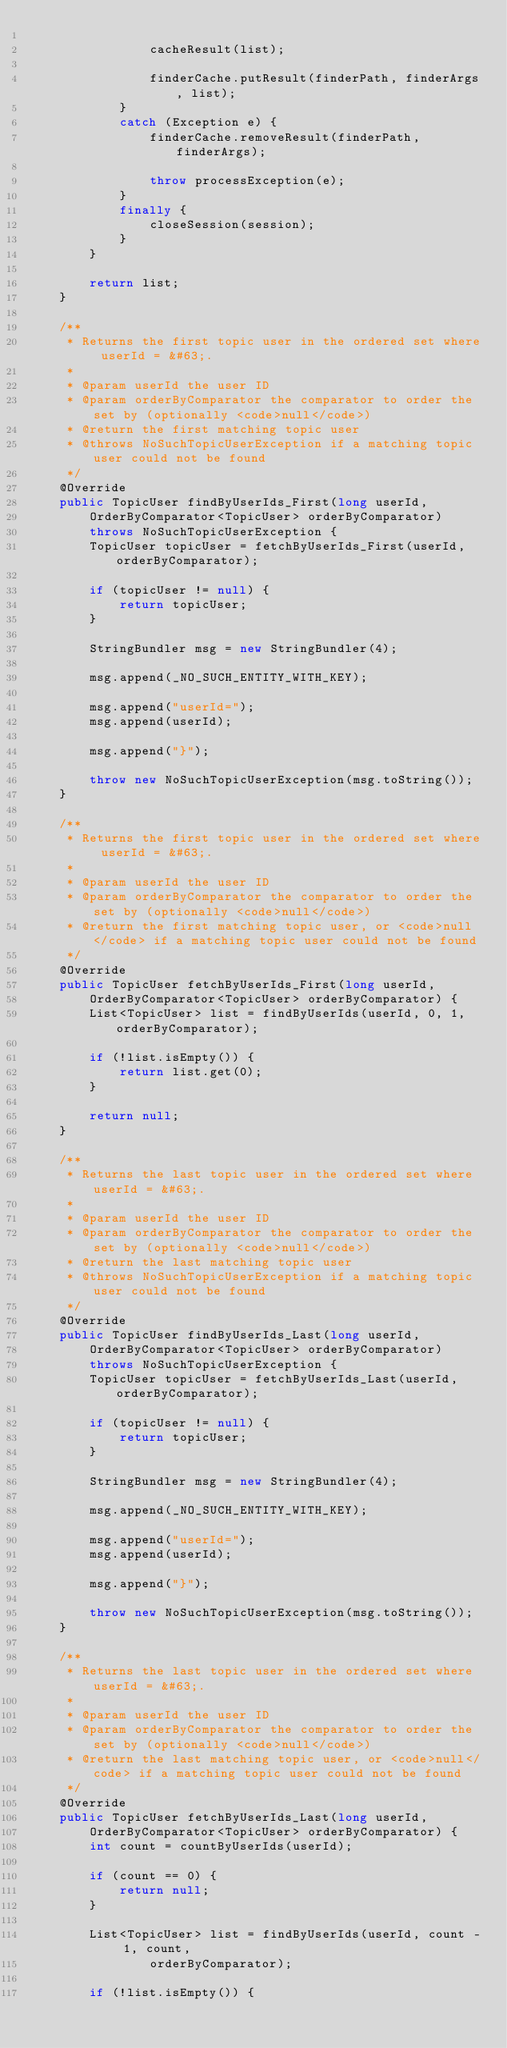<code> <loc_0><loc_0><loc_500><loc_500><_Java_>
				cacheResult(list);

				finderCache.putResult(finderPath, finderArgs, list);
			}
			catch (Exception e) {
				finderCache.removeResult(finderPath, finderArgs);

				throw processException(e);
			}
			finally {
				closeSession(session);
			}
		}

		return list;
	}

	/**
	 * Returns the first topic user in the ordered set where userId = &#63;.
	 *
	 * @param userId the user ID
	 * @param orderByComparator the comparator to order the set by (optionally <code>null</code>)
	 * @return the first matching topic user
	 * @throws NoSuchTopicUserException if a matching topic user could not be found
	 */
	@Override
	public TopicUser findByUserIds_First(long userId,
		OrderByComparator<TopicUser> orderByComparator)
		throws NoSuchTopicUserException {
		TopicUser topicUser = fetchByUserIds_First(userId, orderByComparator);

		if (topicUser != null) {
			return topicUser;
		}

		StringBundler msg = new StringBundler(4);

		msg.append(_NO_SUCH_ENTITY_WITH_KEY);

		msg.append("userId=");
		msg.append(userId);

		msg.append("}");

		throw new NoSuchTopicUserException(msg.toString());
	}

	/**
	 * Returns the first topic user in the ordered set where userId = &#63;.
	 *
	 * @param userId the user ID
	 * @param orderByComparator the comparator to order the set by (optionally <code>null</code>)
	 * @return the first matching topic user, or <code>null</code> if a matching topic user could not be found
	 */
	@Override
	public TopicUser fetchByUserIds_First(long userId,
		OrderByComparator<TopicUser> orderByComparator) {
		List<TopicUser> list = findByUserIds(userId, 0, 1, orderByComparator);

		if (!list.isEmpty()) {
			return list.get(0);
		}

		return null;
	}

	/**
	 * Returns the last topic user in the ordered set where userId = &#63;.
	 *
	 * @param userId the user ID
	 * @param orderByComparator the comparator to order the set by (optionally <code>null</code>)
	 * @return the last matching topic user
	 * @throws NoSuchTopicUserException if a matching topic user could not be found
	 */
	@Override
	public TopicUser findByUserIds_Last(long userId,
		OrderByComparator<TopicUser> orderByComparator)
		throws NoSuchTopicUserException {
		TopicUser topicUser = fetchByUserIds_Last(userId, orderByComparator);

		if (topicUser != null) {
			return topicUser;
		}

		StringBundler msg = new StringBundler(4);

		msg.append(_NO_SUCH_ENTITY_WITH_KEY);

		msg.append("userId=");
		msg.append(userId);

		msg.append("}");

		throw new NoSuchTopicUserException(msg.toString());
	}

	/**
	 * Returns the last topic user in the ordered set where userId = &#63;.
	 *
	 * @param userId the user ID
	 * @param orderByComparator the comparator to order the set by (optionally <code>null</code>)
	 * @return the last matching topic user, or <code>null</code> if a matching topic user could not be found
	 */
	@Override
	public TopicUser fetchByUserIds_Last(long userId,
		OrderByComparator<TopicUser> orderByComparator) {
		int count = countByUserIds(userId);

		if (count == 0) {
			return null;
		}

		List<TopicUser> list = findByUserIds(userId, count - 1, count,
				orderByComparator);

		if (!list.isEmpty()) {</code> 